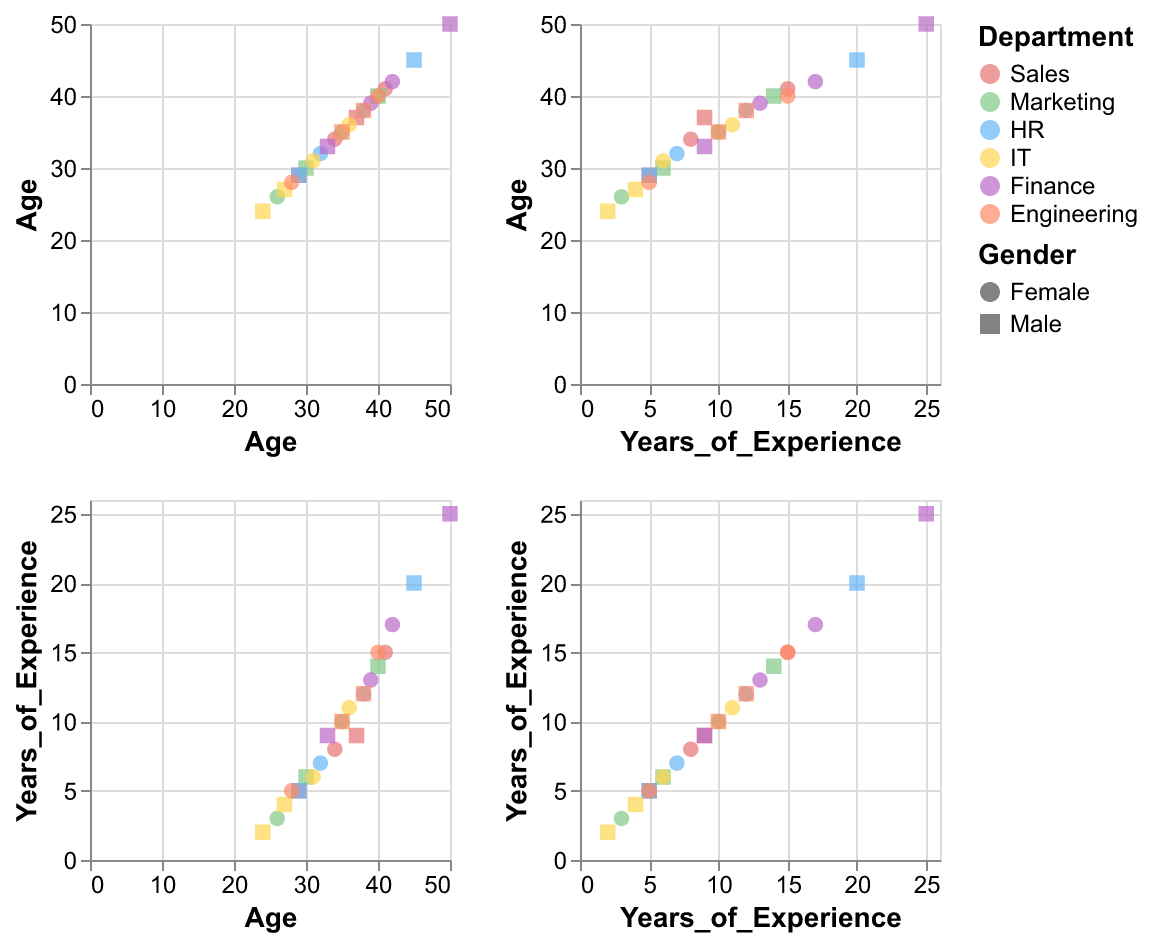How many data points represent the Sales department? Identify the color associated with the Sales department and count the corresponding data points in the scatter plot matrix.
Answer: 4 Which department has the highest average age? Calculate the average age for each department and compare them to identify the maximum.
Answer: Finance What is the typical shape for female employees, and which color represents the HR department? Female employees have a specific shape based on the legend, and HR is represented by a specific color.
Answer: Circle, Blue How does the distribution of years of experience differ between IT and Engineering departments? Compare the range and concentration of years of experience for IT and Engineering departments by observing the scatter plots.
Answer: Engineering tends to have higher years of experience than IT What is a common trend between age and years of experience across different departments? Analyze the scatter plots to identify any common relationships or patterns between age and years of experience.
Answer: Generally, older employees have more years of experience Which gender has more data points in the Finance department? Identify the shape representing each gender and count the corresponding data points within the Finance department color.
Answer: Male Are there more male or female employees across all departments? Tally the data points for each gender across the scatter plot matrix to determine which has more.
Answer: Male Does any ethnic group dominate any single department? Observe the scatter plots to see if a particular ethnicity is more prevalent in any department.
Answer: White in Sales and Hispanic in Engineering (dominance is relative) Which department shows the most age diversity? Check the range of ages in each department's scatter plot to determine which has the widest age spread.
Answer: Sales How many data points correspond to female employees with over 10 years of experience? Identify the scatter plot points for females and count those with years of experience above 10.
Answer: 6 